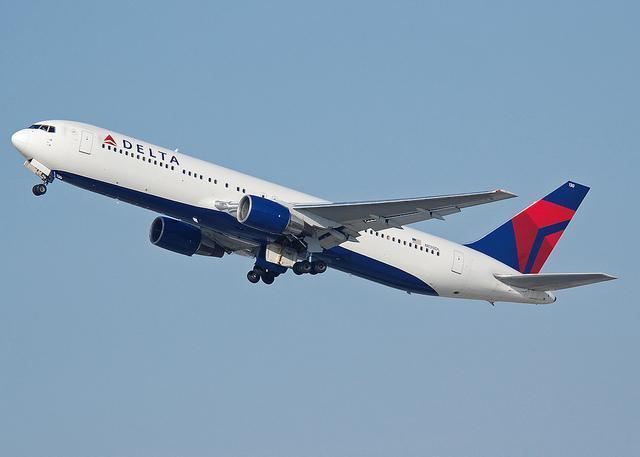How many airplanes can you see?
Give a very brief answer. 1. 